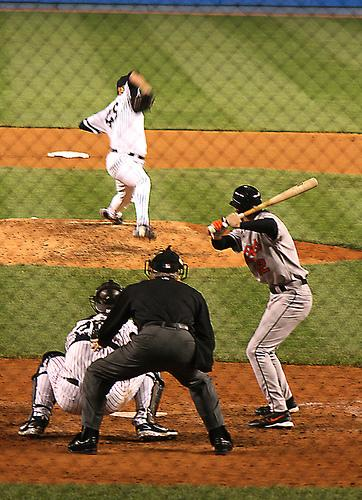Refer to the pitcher's actions and comment on their form. The pitcher is using good form while preparing to throw the ball. Write a vivid description of the scene happening around home plate. A group of men congregates around home plate, playing an intense game of baseball, striking both in concentration and determination as they compete. In one brief sentence, mention what the pitcher, the batter, and the umpire are doing. The pitcher throws the ball, the batter braces with bat in hand, and the umpire stands watchful. Provide a brief overview of the main actions happening in the image. The pitcher is throwing the ball, the batter holds a wooden bat ready to hit, the catcher squats behind, and the umpire watches closely. Describe the appearance of the bat and what it is made of. The bat is wooden and is being held by the batter. Using poetic language, describe the central activity depicted in the image. Amidst vibrant greens and dirt so brown, a pitcher gracefully winds and hurls, while batter poised with wooden bat, readies for a swing where dreams unfurl. Mention the type and colors of the shoes worn by the tennis player. The tennis player's shoes are black and white. What can you say about the ground and the grass? There is dirt on the ground and the grass is green and trimmed. What is the catcher's outfit, and what can you see on his head? The catcher is wearing a baseball uniform and a black helmet on his head. Describe the fencing in the image. There is a chain link fence behind the players. 